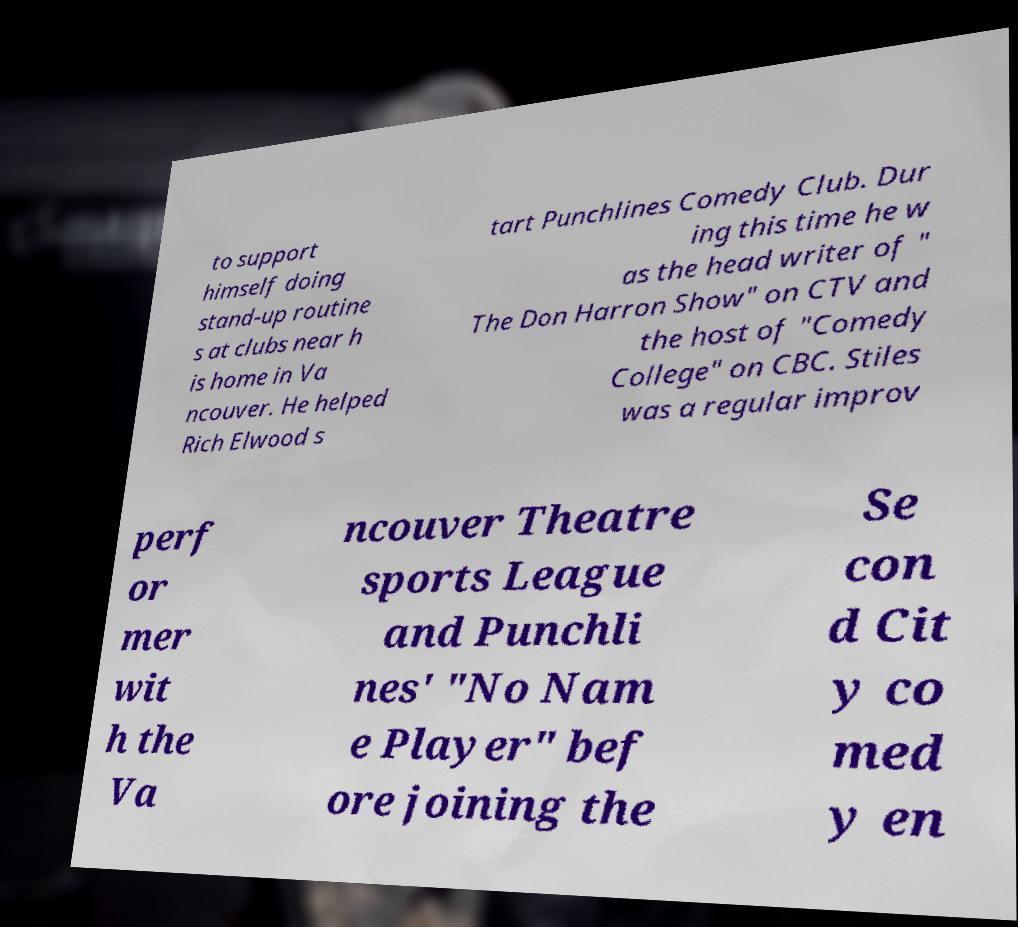For documentation purposes, I need the text within this image transcribed. Could you provide that? to support himself doing stand-up routine s at clubs near h is home in Va ncouver. He helped Rich Elwood s tart Punchlines Comedy Club. Dur ing this time he w as the head writer of " The Don Harron Show" on CTV and the host of "Comedy College" on CBC. Stiles was a regular improv perf or mer wit h the Va ncouver Theatre sports League and Punchli nes' "No Nam e Player" bef ore joining the Se con d Cit y co med y en 